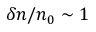<formula> <loc_0><loc_0><loc_500><loc_500>\delta n / n _ { 0 } \sim 1</formula> 